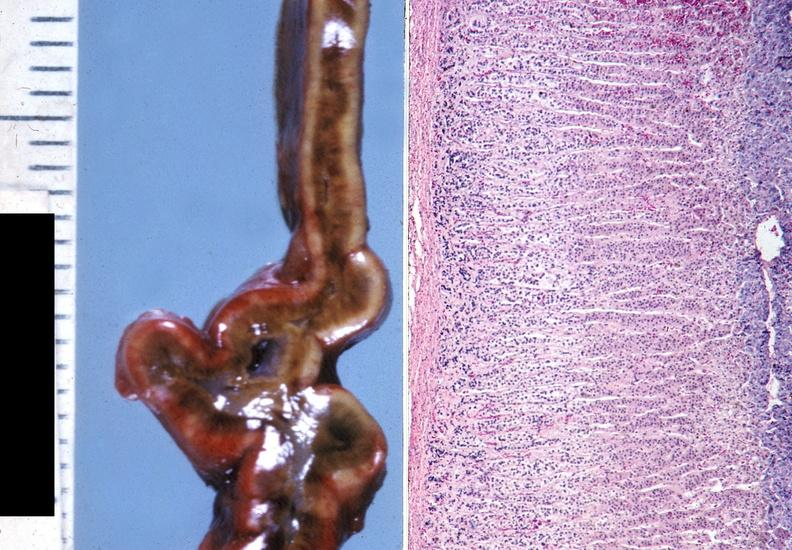s endocrine present?
Answer the question using a single word or phrase. Yes 